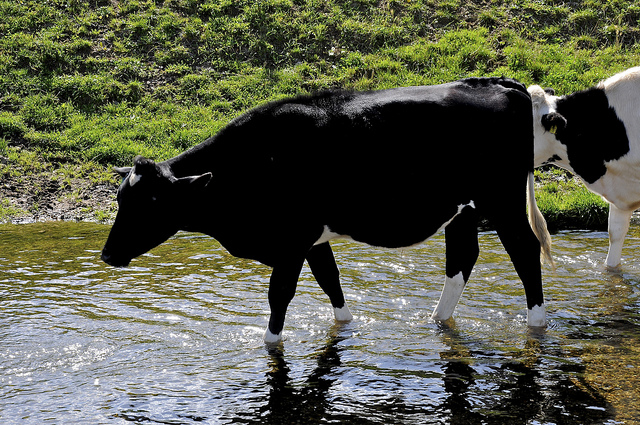<image>What type of liquid is this man gathering? It is ambiguous to say what type of liquid the man is gathering. It could be water or milk. What number is tagged on the cow? It is unclear what number is tagged on the cow. The number could be 0, 1, 2 or there might not be a number at all. What number is tagged on the cow? I don't know what number is tagged on the cow. It is not visible in the image. What type of liquid is this man gathering? I don't know what type of liquid the man is gathering. It can be water or milk. 